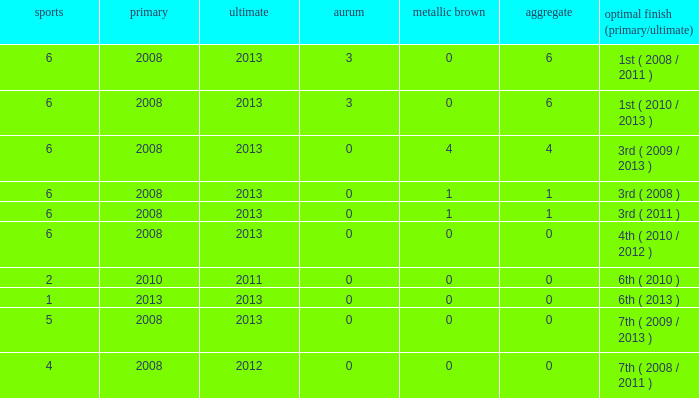How many games are associated with over 0 golds and a first year before 2008? None. Give me the full table as a dictionary. {'header': ['sports', 'primary', 'ultimate', 'aurum', 'metallic brown', 'aggregate', 'optimal finish (primary/ultimate)'], 'rows': [['6', '2008', '2013', '3', '0', '6', '1st ( 2008 / 2011 )'], ['6', '2008', '2013', '3', '0', '6', '1st ( 2010 / 2013 )'], ['6', '2008', '2013', '0', '4', '4', '3rd ( 2009 / 2013 )'], ['6', '2008', '2013', '0', '1', '1', '3rd ( 2008 )'], ['6', '2008', '2013', '0', '1', '1', '3rd ( 2011 )'], ['6', '2008', '2013', '0', '0', '0', '4th ( 2010 / 2012 )'], ['2', '2010', '2011', '0', '0', '0', '6th ( 2010 )'], ['1', '2013', '2013', '0', '0', '0', '6th ( 2013 )'], ['5', '2008', '2013', '0', '0', '0', '7th ( 2009 / 2013 )'], ['4', '2008', '2012', '0', '0', '0', '7th ( 2008 / 2011 )']]} 